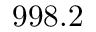<formula> <loc_0><loc_0><loc_500><loc_500>9 9 8 . 2</formula> 